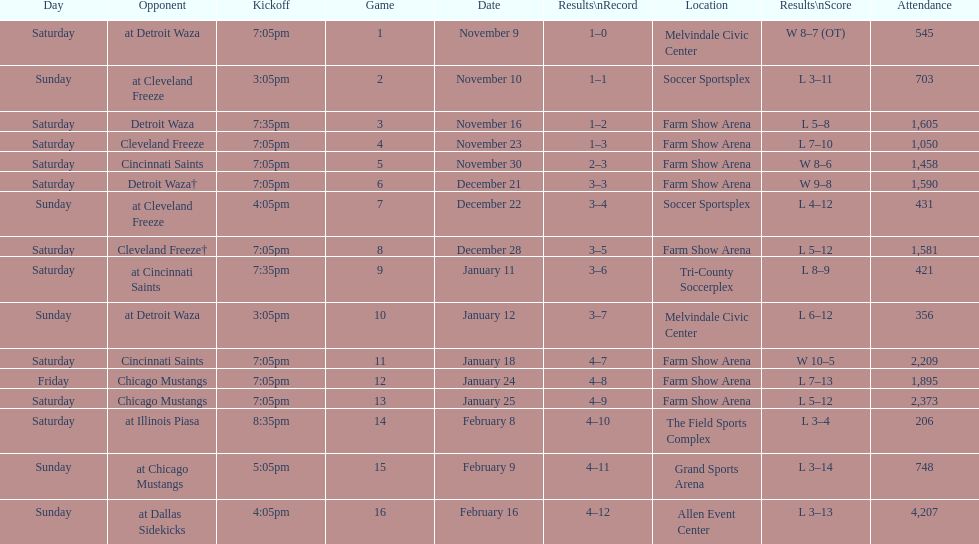What was the location before tri-county soccerplex? Farm Show Arena. 